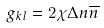Convert formula to latex. <formula><loc_0><loc_0><loc_500><loc_500>g _ { k l } = 2 \chi \Delta n \overline { n }</formula> 